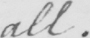Transcribe the text shown in this historical manuscript line. all . 